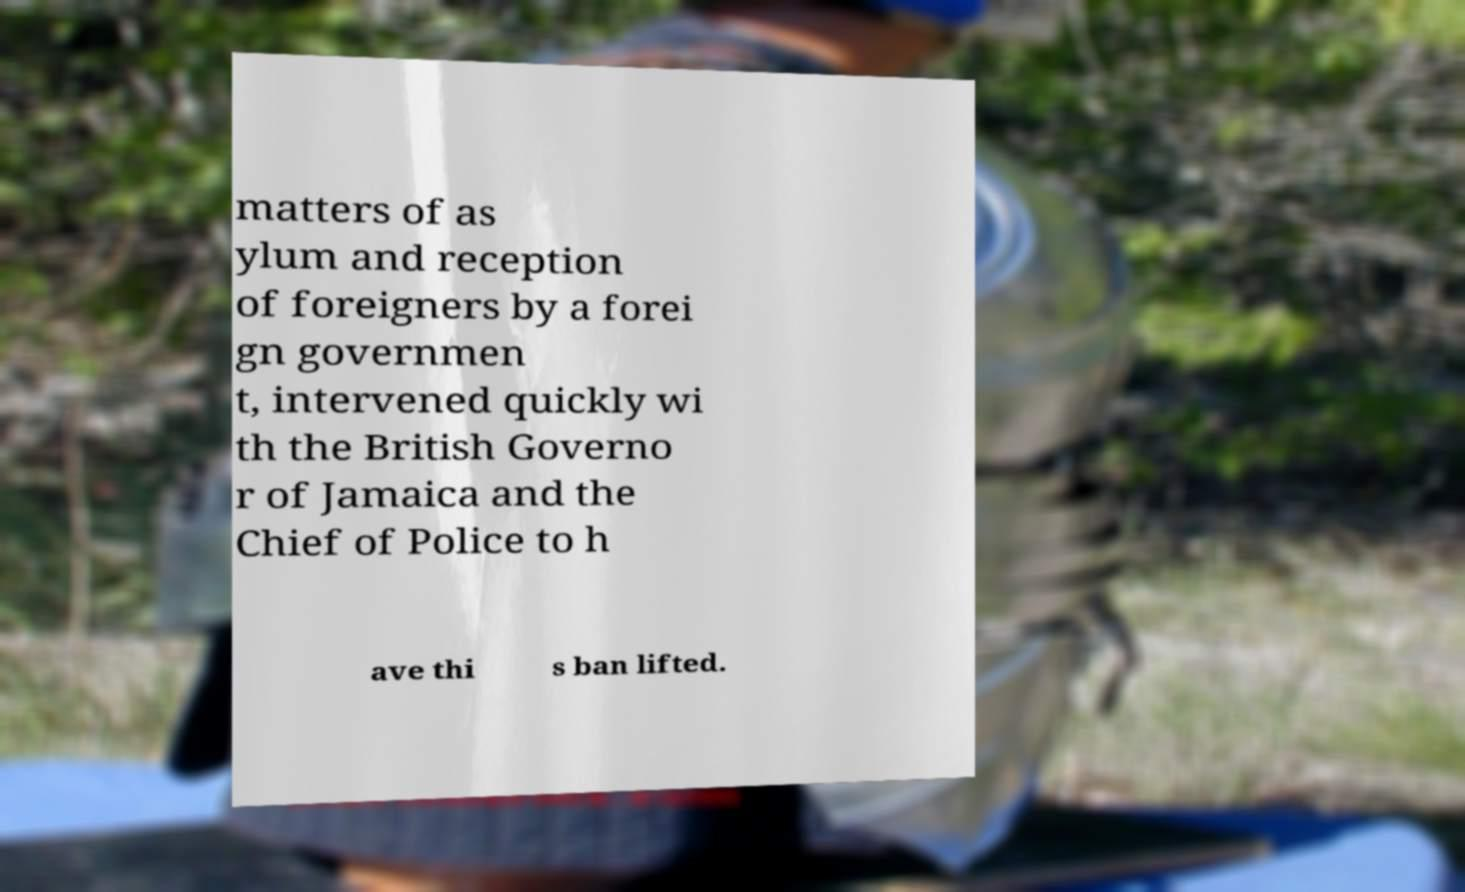Could you assist in decoding the text presented in this image and type it out clearly? matters of as ylum and reception of foreigners by a forei gn governmen t, intervened quickly wi th the British Governo r of Jamaica and the Chief of Police to h ave thi s ban lifted. 